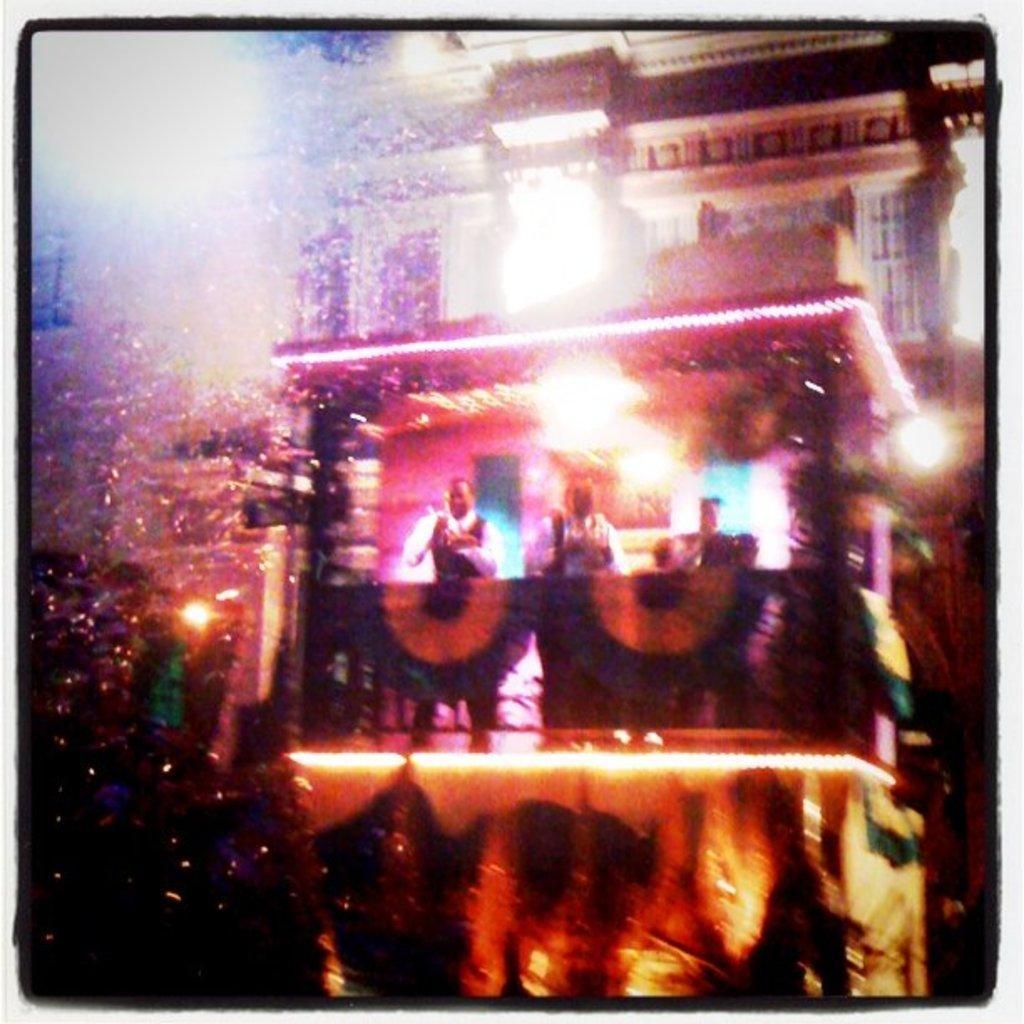Can you describe this image briefly? In this image in the center there is a building and there are three persons standing, and also i can see some lights and some other objects. 